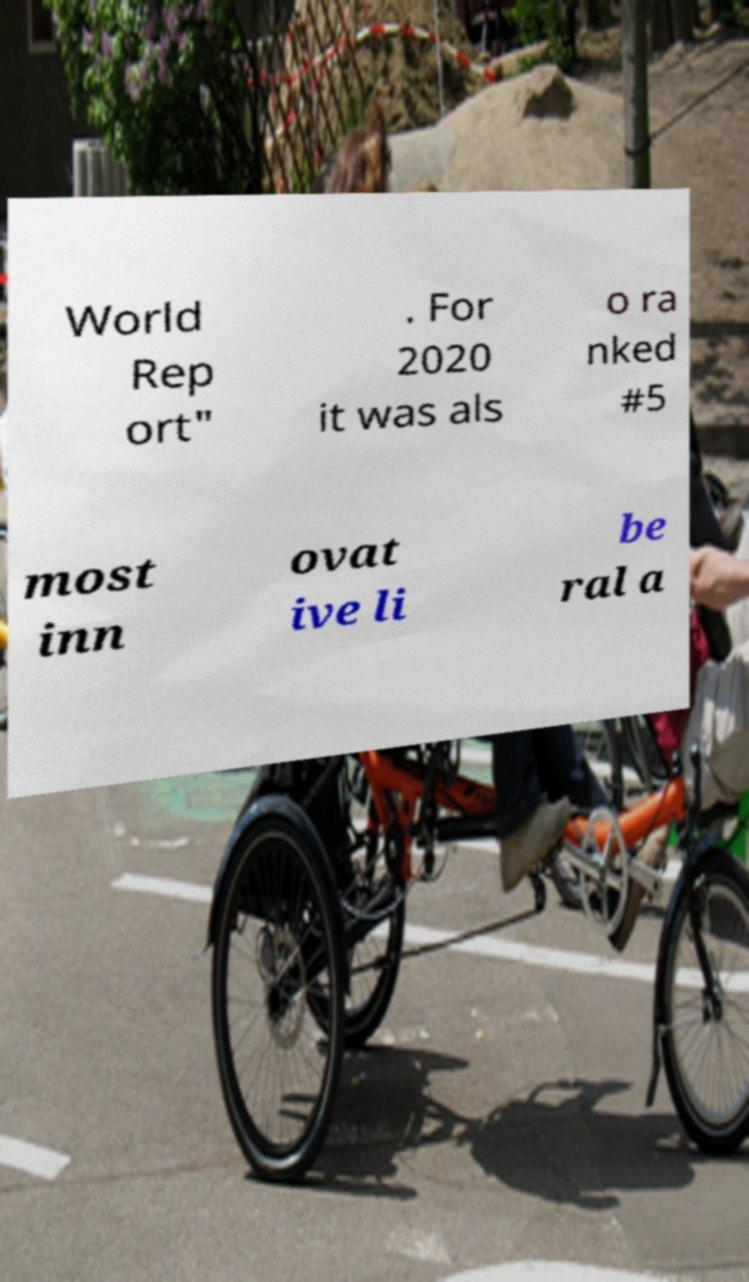Could you assist in decoding the text presented in this image and type it out clearly? World Rep ort" . For 2020 it was als o ra nked #5 most inn ovat ive li be ral a 